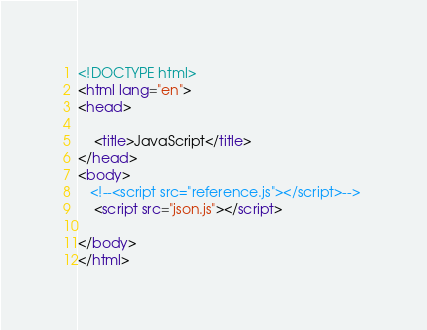Convert code to text. <code><loc_0><loc_0><loc_500><loc_500><_HTML_><!DOCTYPE html>
<html lang="en">
<head>

    <title>JavaScript</title>
</head>
<body>
   <!--<script src="reference.js"></script>--> 
    <script src="json.js"></script>
    
</body>
</html></code> 